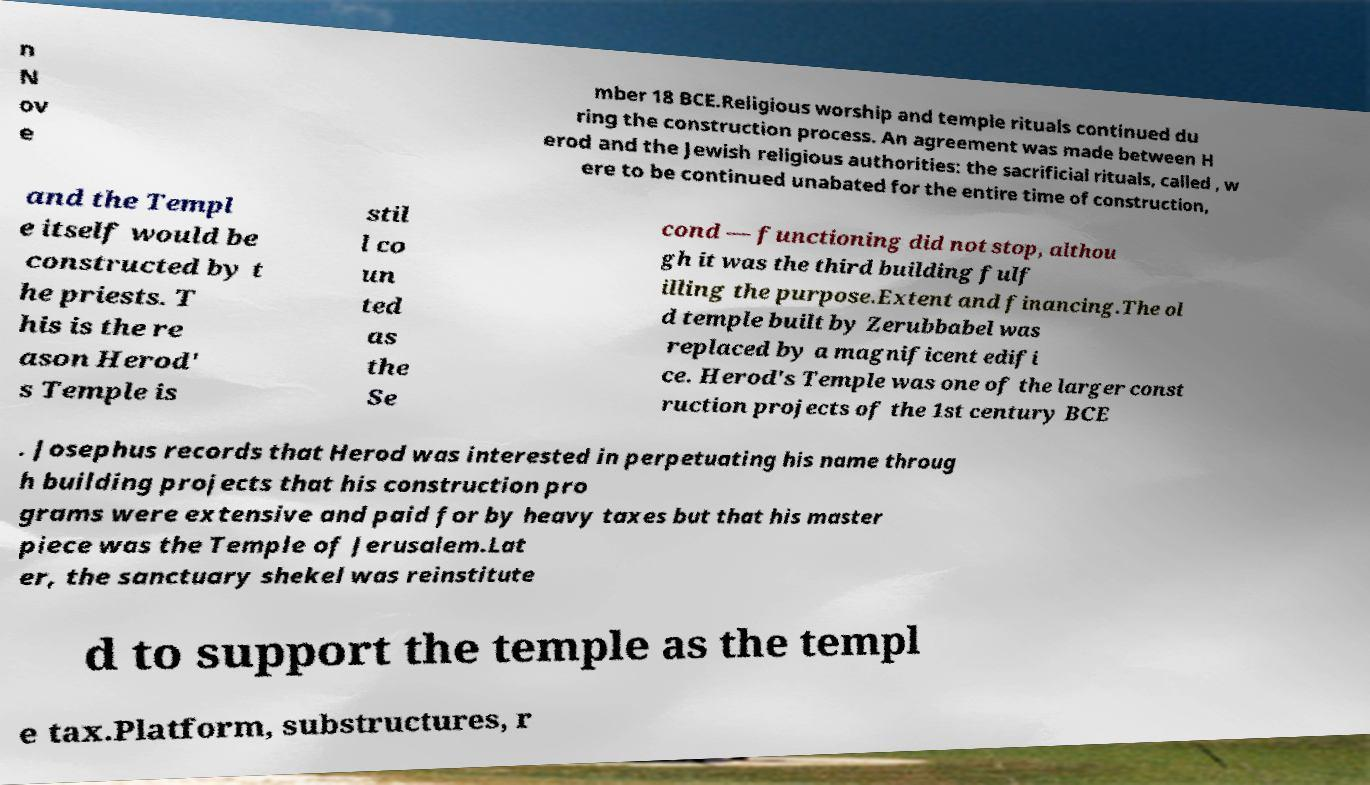Can you accurately transcribe the text from the provided image for me? n N ov e mber 18 BCE.Religious worship and temple rituals continued du ring the construction process. An agreement was made between H erod and the Jewish religious authorities: the sacrificial rituals, called , w ere to be continued unabated for the entire time of construction, and the Templ e itself would be constructed by t he priests. T his is the re ason Herod' s Temple is stil l co un ted as the Se cond — functioning did not stop, althou gh it was the third building fulf illing the purpose.Extent and financing.The ol d temple built by Zerubbabel was replaced by a magnificent edifi ce. Herod's Temple was one of the larger const ruction projects of the 1st century BCE . Josephus records that Herod was interested in perpetuating his name throug h building projects that his construction pro grams were extensive and paid for by heavy taxes but that his master piece was the Temple of Jerusalem.Lat er, the sanctuary shekel was reinstitute d to support the temple as the templ e tax.Platform, substructures, r 